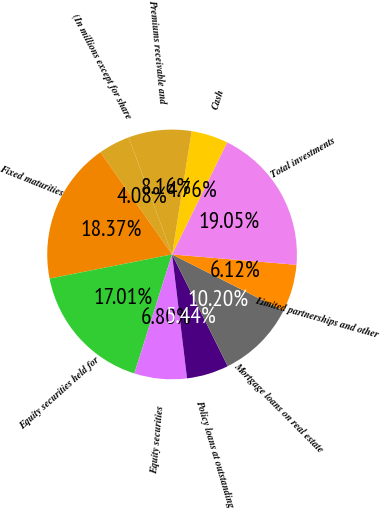<chart> <loc_0><loc_0><loc_500><loc_500><pie_chart><fcel>(In millions except for share<fcel>Fixed maturities<fcel>Equity securities held for<fcel>Equity securities<fcel>Policy loans at outstanding<fcel>Mortgage loans on real estate<fcel>Limited partnerships and other<fcel>Total investments<fcel>Cash<fcel>Premiums receivable and<nl><fcel>4.08%<fcel>18.37%<fcel>17.01%<fcel>6.8%<fcel>5.44%<fcel>10.2%<fcel>6.12%<fcel>19.05%<fcel>4.76%<fcel>8.16%<nl></chart> 